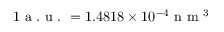<formula> <loc_0><loc_0><loc_500><loc_500>1 a . u . = 1 . 4 8 1 8 \times 1 0 ^ { - 4 } n m ^ { 3 }</formula> 